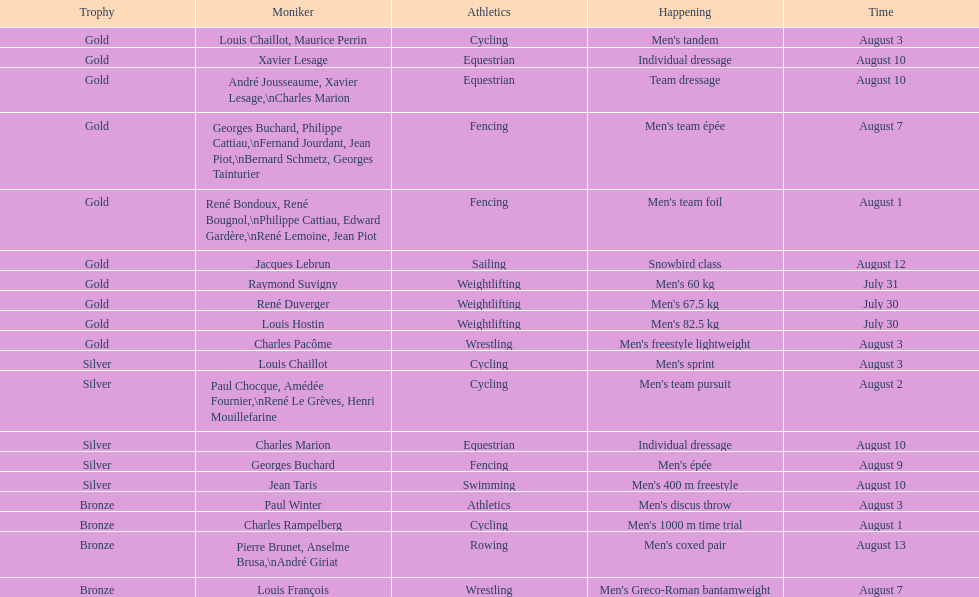What event is listed right before team dressage? Individual dressage. 